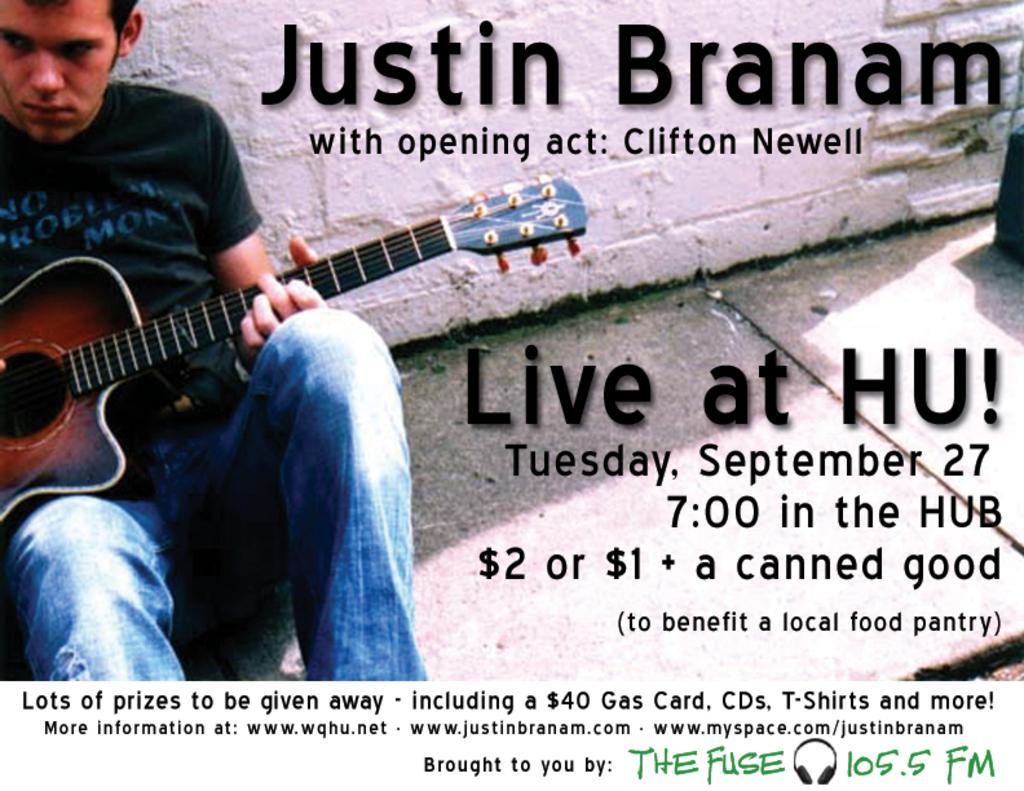In one or two sentences, can you explain what this image depicts? In this image I can see a man is playing guitar. I can also see the man is wearing a black t-shirt and blue jeans. 